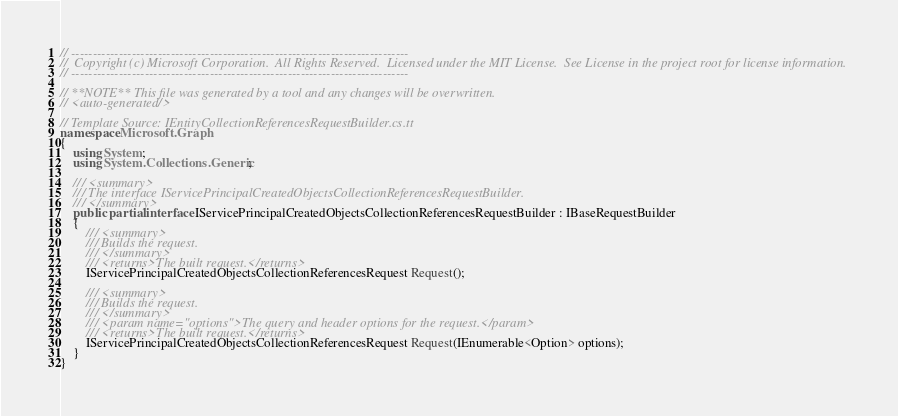<code> <loc_0><loc_0><loc_500><loc_500><_C#_>// ------------------------------------------------------------------------------
//  Copyright (c) Microsoft Corporation.  All Rights Reserved.  Licensed under the MIT License.  See License in the project root for license information.
// ------------------------------------------------------------------------------

// **NOTE** This file was generated by a tool and any changes will be overwritten.
// <auto-generated/>

// Template Source: IEntityCollectionReferencesRequestBuilder.cs.tt
namespace Microsoft.Graph
{
    using System;
    using System.Collections.Generic;

    /// <summary>
    /// The interface IServicePrincipalCreatedObjectsCollectionReferencesRequestBuilder.
    /// </summary>
    public partial interface IServicePrincipalCreatedObjectsCollectionReferencesRequestBuilder : IBaseRequestBuilder
    {
        /// <summary>
        /// Builds the request.
        /// </summary>
        /// <returns>The built request.</returns>
        IServicePrincipalCreatedObjectsCollectionReferencesRequest Request();

        /// <summary>
        /// Builds the request.
        /// </summary>
        /// <param name="options">The query and header options for the request.</param>
        /// <returns>The built request.</returns>
        IServicePrincipalCreatedObjectsCollectionReferencesRequest Request(IEnumerable<Option> options);
    }
}
</code> 